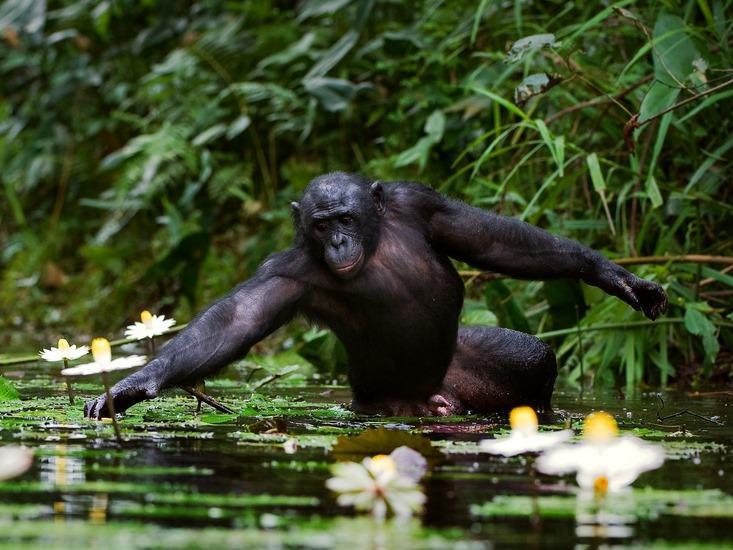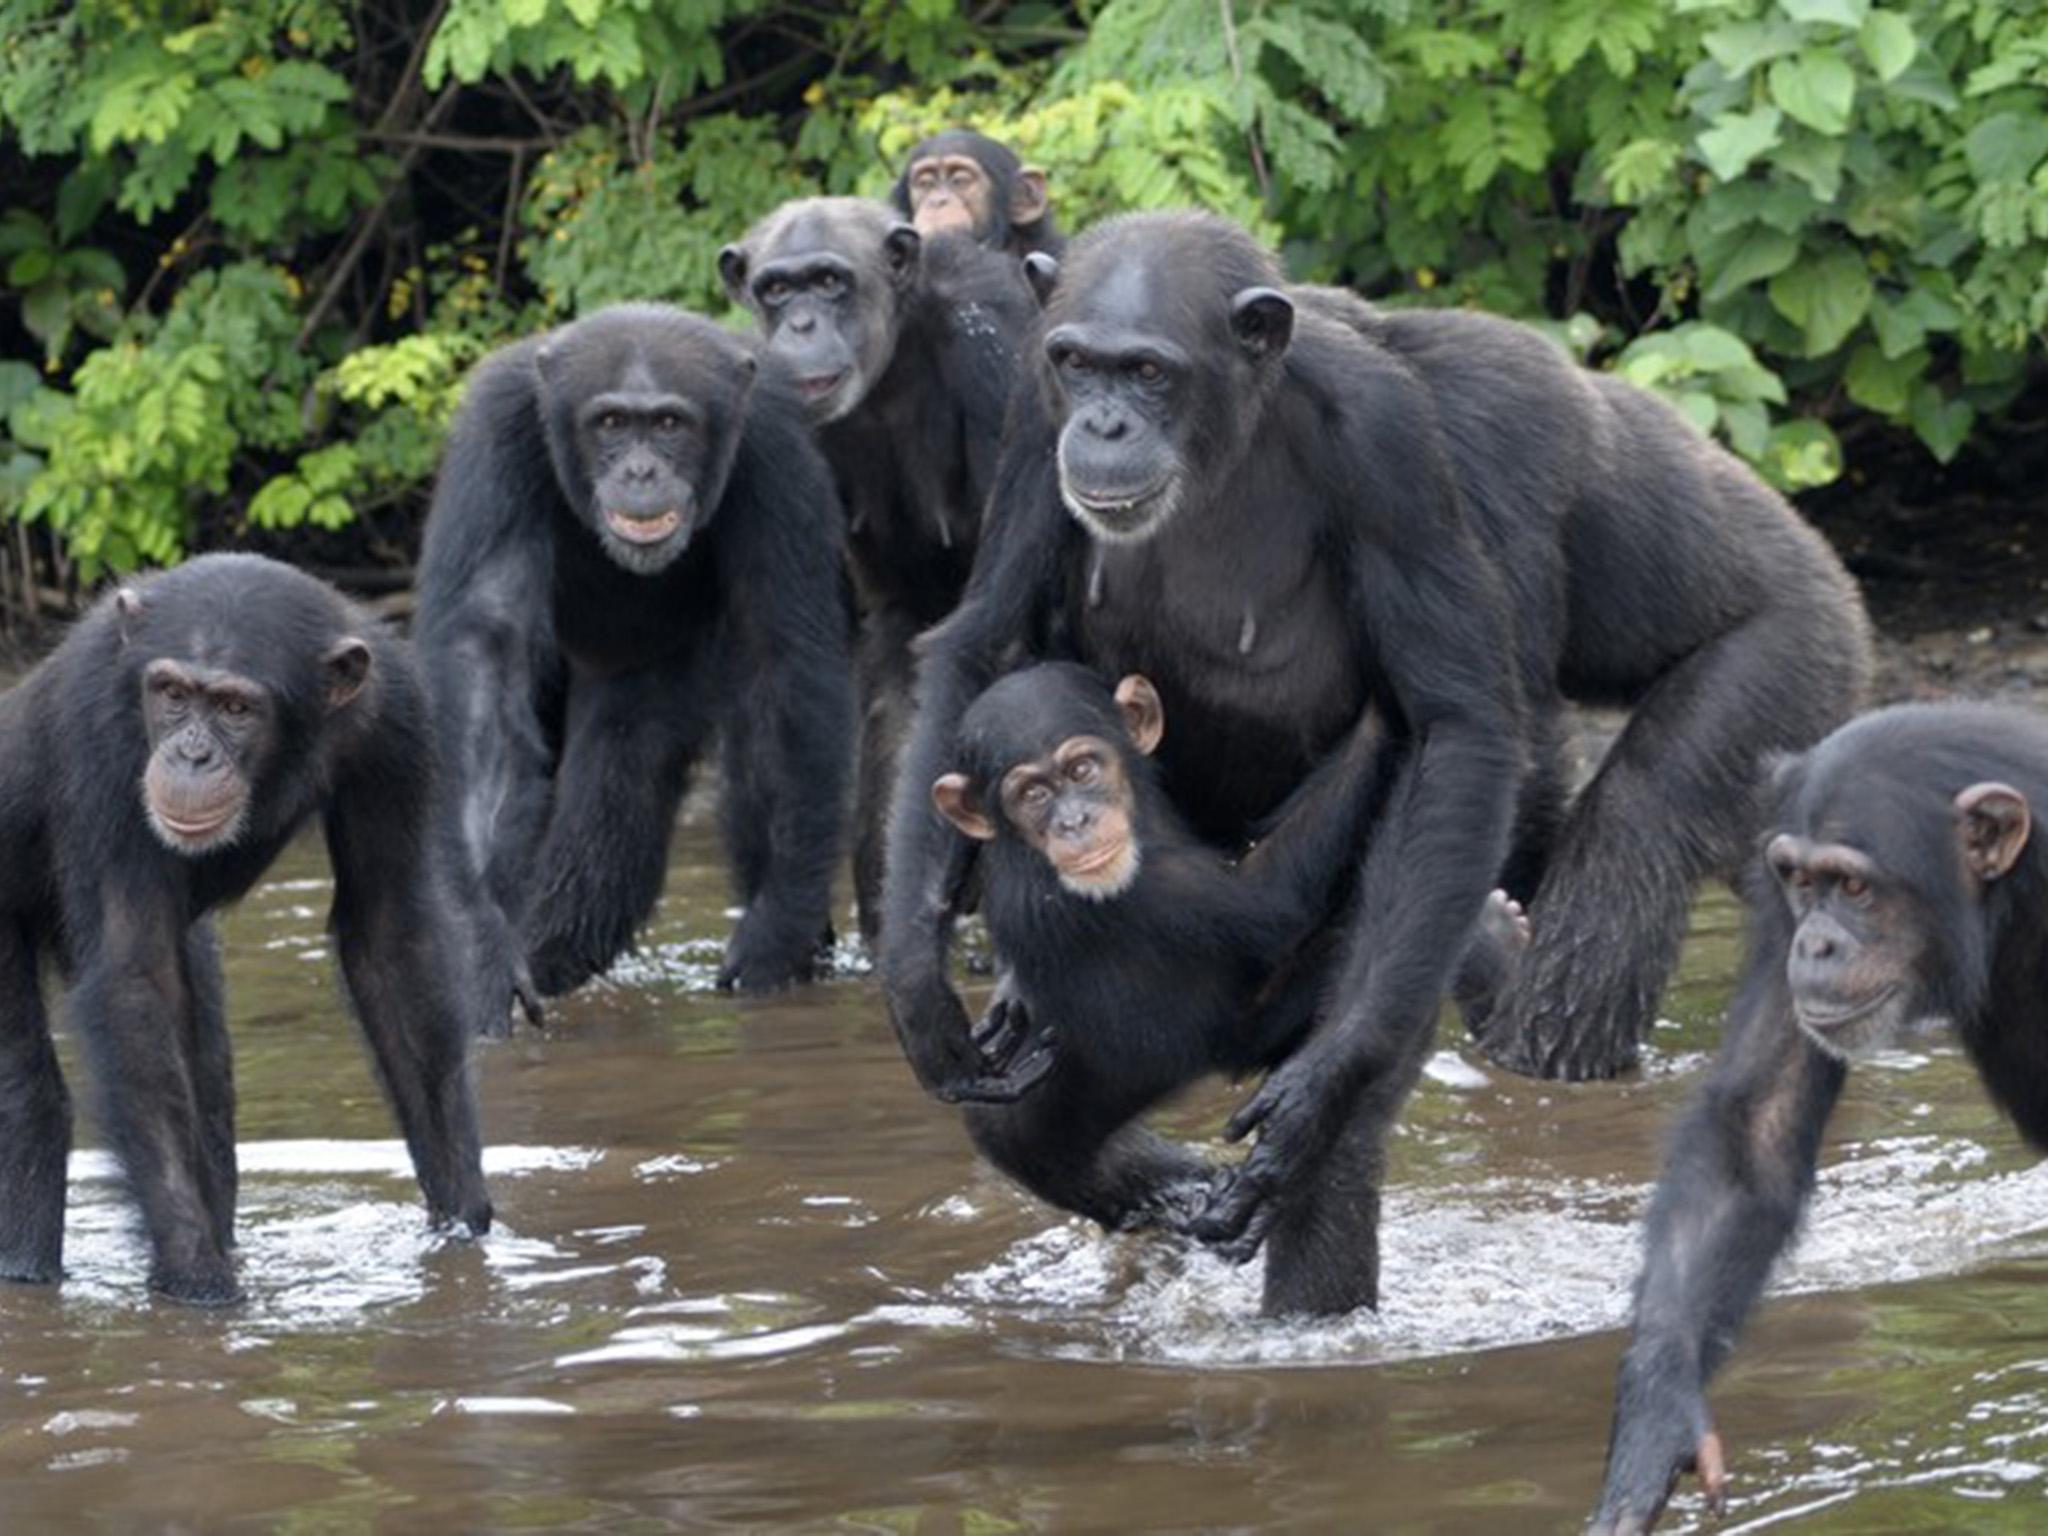The first image is the image on the left, the second image is the image on the right. Analyze the images presented: Is the assertion "The right image contains exactly two chimpanzees." valid? Answer yes or no. No. The first image is the image on the left, the second image is the image on the right. Given the left and right images, does the statement "One image shows no more than three chimps, who are near one another in a grassy field,  and the other image includes a chimp at the edge of a small pool sunken in the ground." hold true? Answer yes or no. No. 